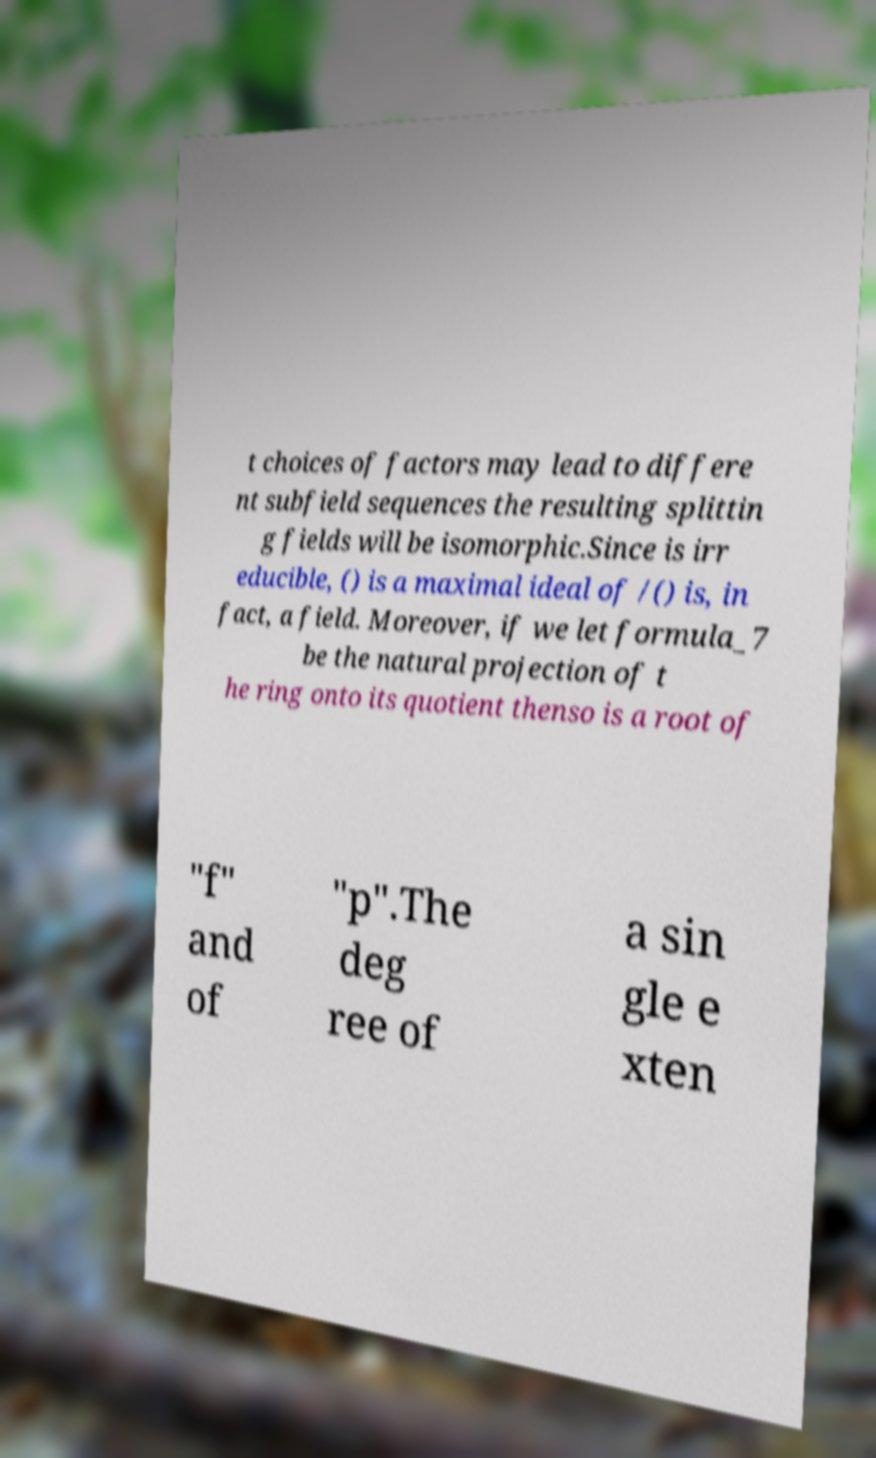Please read and relay the text visible in this image. What does it say? t choices of factors may lead to differe nt subfield sequences the resulting splittin g fields will be isomorphic.Since is irr educible, () is a maximal ideal of /() is, in fact, a field. Moreover, if we let formula_7 be the natural projection of t he ring onto its quotient thenso is a root of "f" and of "p".The deg ree of a sin gle e xten 